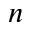<formula> <loc_0><loc_0><loc_500><loc_500>n</formula> 